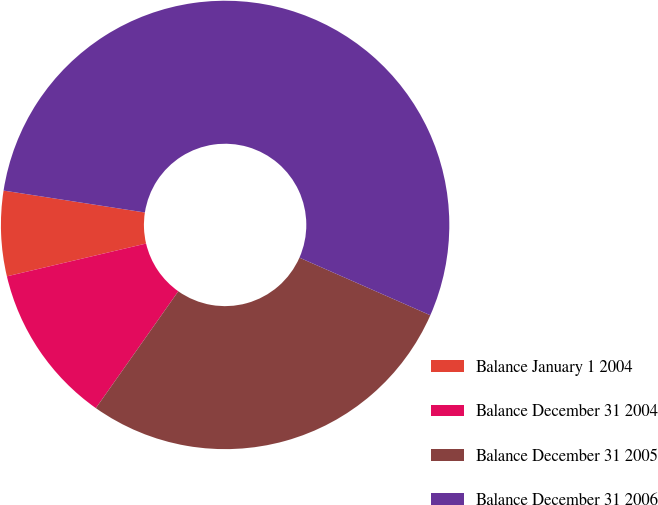<chart> <loc_0><loc_0><loc_500><loc_500><pie_chart><fcel>Balance January 1 2004<fcel>Balance December 31 2004<fcel>Balance December 31 2005<fcel>Balance December 31 2006<nl><fcel>6.13%<fcel>11.54%<fcel>28.18%<fcel>54.15%<nl></chart> 